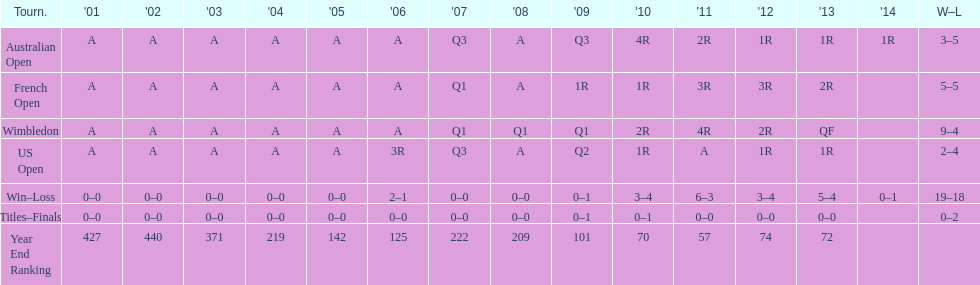What was this players ranking after 2005? 125. 